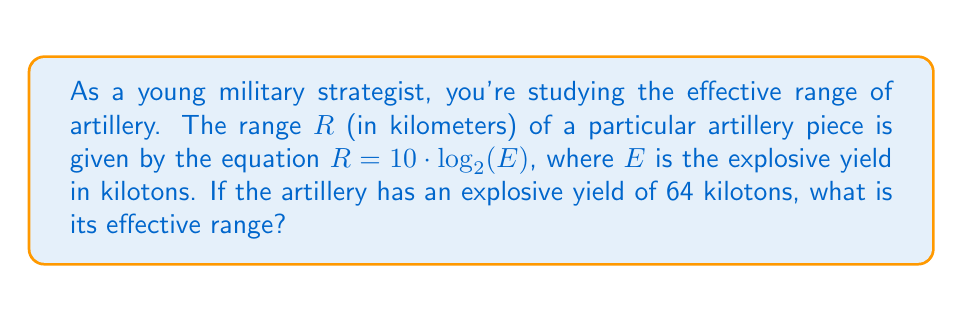Solve this math problem. Let's approach this step-by-step:

1) We are given the equation: $R = 10 \cdot \log_2(E)$

2) We know that $E = 64$ kilotons

3) Let's substitute this into our equation:
   $R = 10 \cdot \log_2(64)$

4) Now, we need to evaluate $\log_2(64)$:
   
   $2^6 = 64$, therefore $\log_2(64) = 6$

5) Substituting this back into our equation:
   $R = 10 \cdot 6$

6) Finally, we calculate:
   $R = 60$

Therefore, the effective range of the artillery is 60 kilometers.
Answer: 60 km 